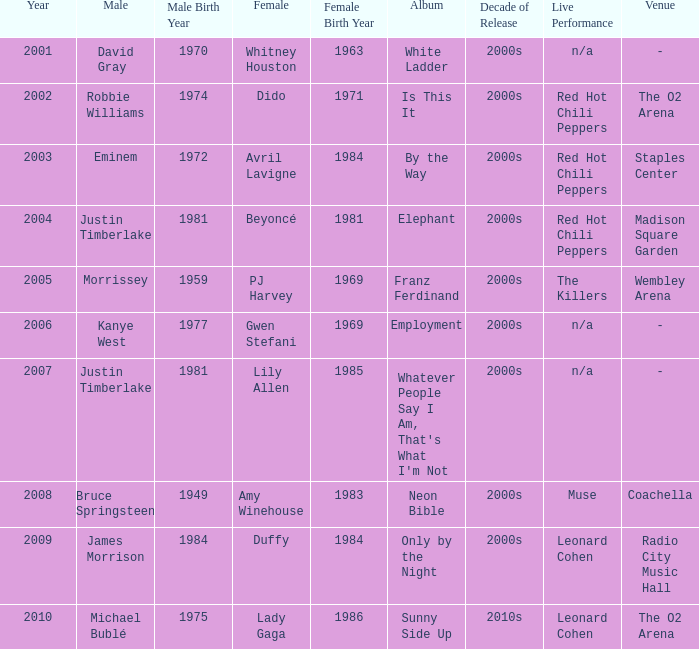Which male is paired with dido in 2004? Robbie Williams. 